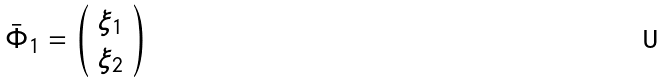Convert formula to latex. <formula><loc_0><loc_0><loc_500><loc_500>\bar { \Phi } _ { 1 } = \left ( \begin{array} { c } { { \xi _ { 1 } } } \\ { { \xi _ { 2 } } } \end{array} \right )</formula> 